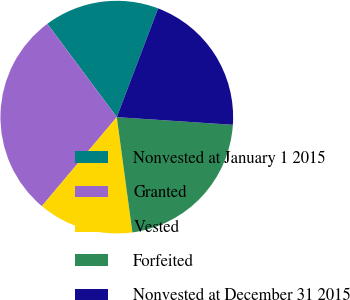<chart> <loc_0><loc_0><loc_500><loc_500><pie_chart><fcel>Nonvested at January 1 2015<fcel>Granted<fcel>Vested<fcel>Forfeited<fcel>Nonvested at December 31 2015<nl><fcel>15.96%<fcel>28.68%<fcel>13.28%<fcel>21.81%<fcel>20.27%<nl></chart> 